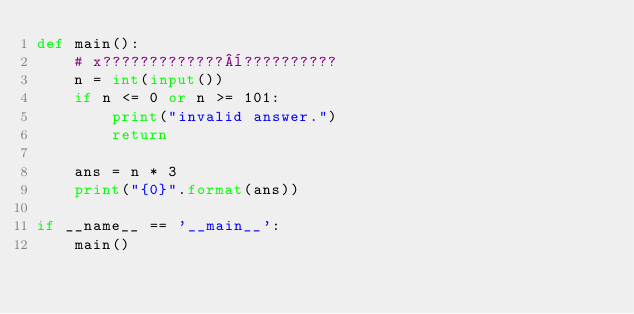<code> <loc_0><loc_0><loc_500><loc_500><_Python_>def main():
    # x?????????????¨??????????
    n = int(input())
    if n <= 0 or n >= 101:
        print("invalid answer.")
        return

    ans = n * 3
    print("{0}".format(ans))

if __name__ == '__main__':
    main()</code> 